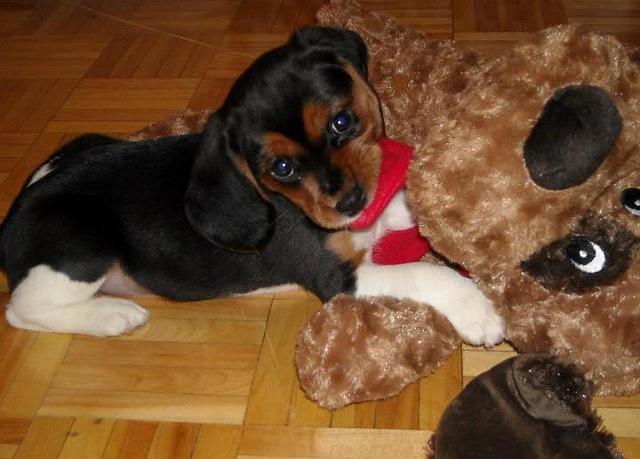Is the puppy going to chew the stuffed animal?
Concise answer only. Yes. Do you think that dog is growling?
Concise answer only. No. Which is larger: the puppy or the stuffed animal?
Keep it brief. Stuffed animal. Is this dog less than 2 years old?
Answer briefly. Yes. What kind of animal is the dog toy?
Concise answer only. Dog. What color are the dogs paws?
Write a very short answer. White. Does the puppy love the stuffed animal?
Keep it brief. Yes. Is this a large or small dog?
Concise answer only. Small. What is the dog doing?
Concise answer only. Laying. What is unique about the relationship between these two animals?
Concise answer only. One is stuffed. Does the puppy and the stuffed bear have the same colored nose?
Short answer required. Yes. What is the toy between the dog's paws?
Be succinct. Stuffed animal. 